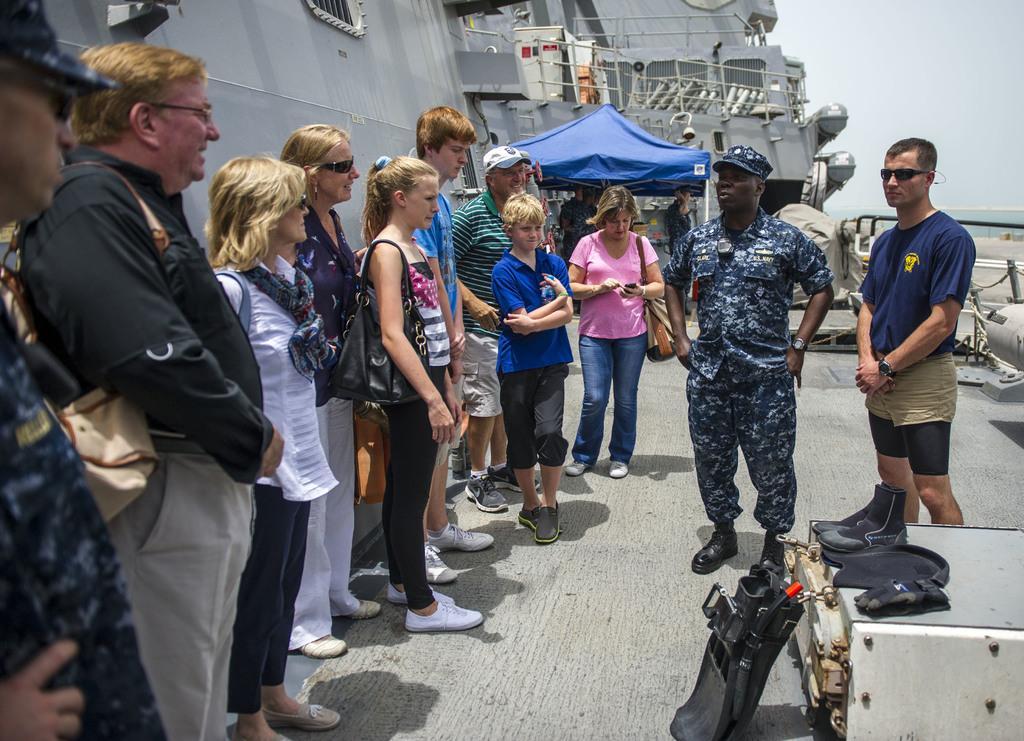Can you describe this image briefly? In this image there are group of people, a stall and some other items in a ship, which is on the water, and in the background there is sky. 